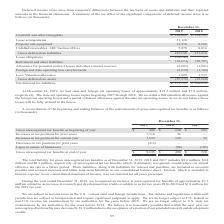According to Mantech International's financial document, What does the table show us? A reconciliation of the beginning and ending balances of the total amounts of gross unrecognized tax benefits. The document states: "A reconciliation of the beginning and ending balances of the total amounts of gross unrecognized tax benefits is as follows (in thousands):..." Also, The company believes that it is possible that within the next year, unrecognized tax benefits may decrease by $1.9 million. What causes that decrease? the acceptance of a portion of our amended research and development credits. The document states: "tax benefits may decrease by $1.9 million due to the acceptance of a portion of our amended research and development credits...." Also, What did the increase of approximately $7.7 million in unrecognized tax benefits relate to, during the year ended December 21, 2019? an increase in research and development tax credits available to us for tax years 2016-2018 and $1.8 million for the 2019 tax year.. The document states: "benefits of approximately $7.7 million related to an increase in research and development tax credits available to us for tax years 2016-2018 and $1.8..." Also, can you calculate: What is the percentage change of gross unrecognized tax benefits from the end of the year 2017 to 2018? To answer this question, I need to perform calculations using the financial data. The calculation is: ($490-$220)/$220 , which equals 122.73 (percentage). This is based on the information: "ognized tax benefits at beginning of year $ 490 $ 220 $ 293 Increases in tax positions for prior years 7,718 36 — Increases in tax positions for current unrecognized tax benefits at beginning of year ..." The key data points involved are: 220, 490. Also, can you calculate: What is the proportion of the total increase in tax positions for the prior and current years over gross unrecognized tax benefits at the end of the year 2019? To answer this question, I need to perform calculations using the financial data. The calculation is: (7,718+1,839)/9,635, which equals 0.99. This is based on the information: "36 — Increases in tax positions for current year 1,839 320 32 Decreases in tax positions for prior years (412) — — Lapse in statute of limitations — (86) Gross unrecognized tax benefits at end of year..." The key data points involved are: 1,839, 7,718, 9,635. Also, can you calculate: What is the total lapse in the statute of limitations from 2017 to 2019? Based on the calculation: -105+(-86)+0, the result is -191 (in thousands). This is based on the information: "ears (412) — — Lapse in statute of limitations — (86) (105) Gross unrecognized tax benefits at end of year $ 9,635 $ 490 $ 220 (412) — — Lapse in statute of limitations — (86) (105) Gross unrecognized..." The key data points involved are: 0, 105, 86. 